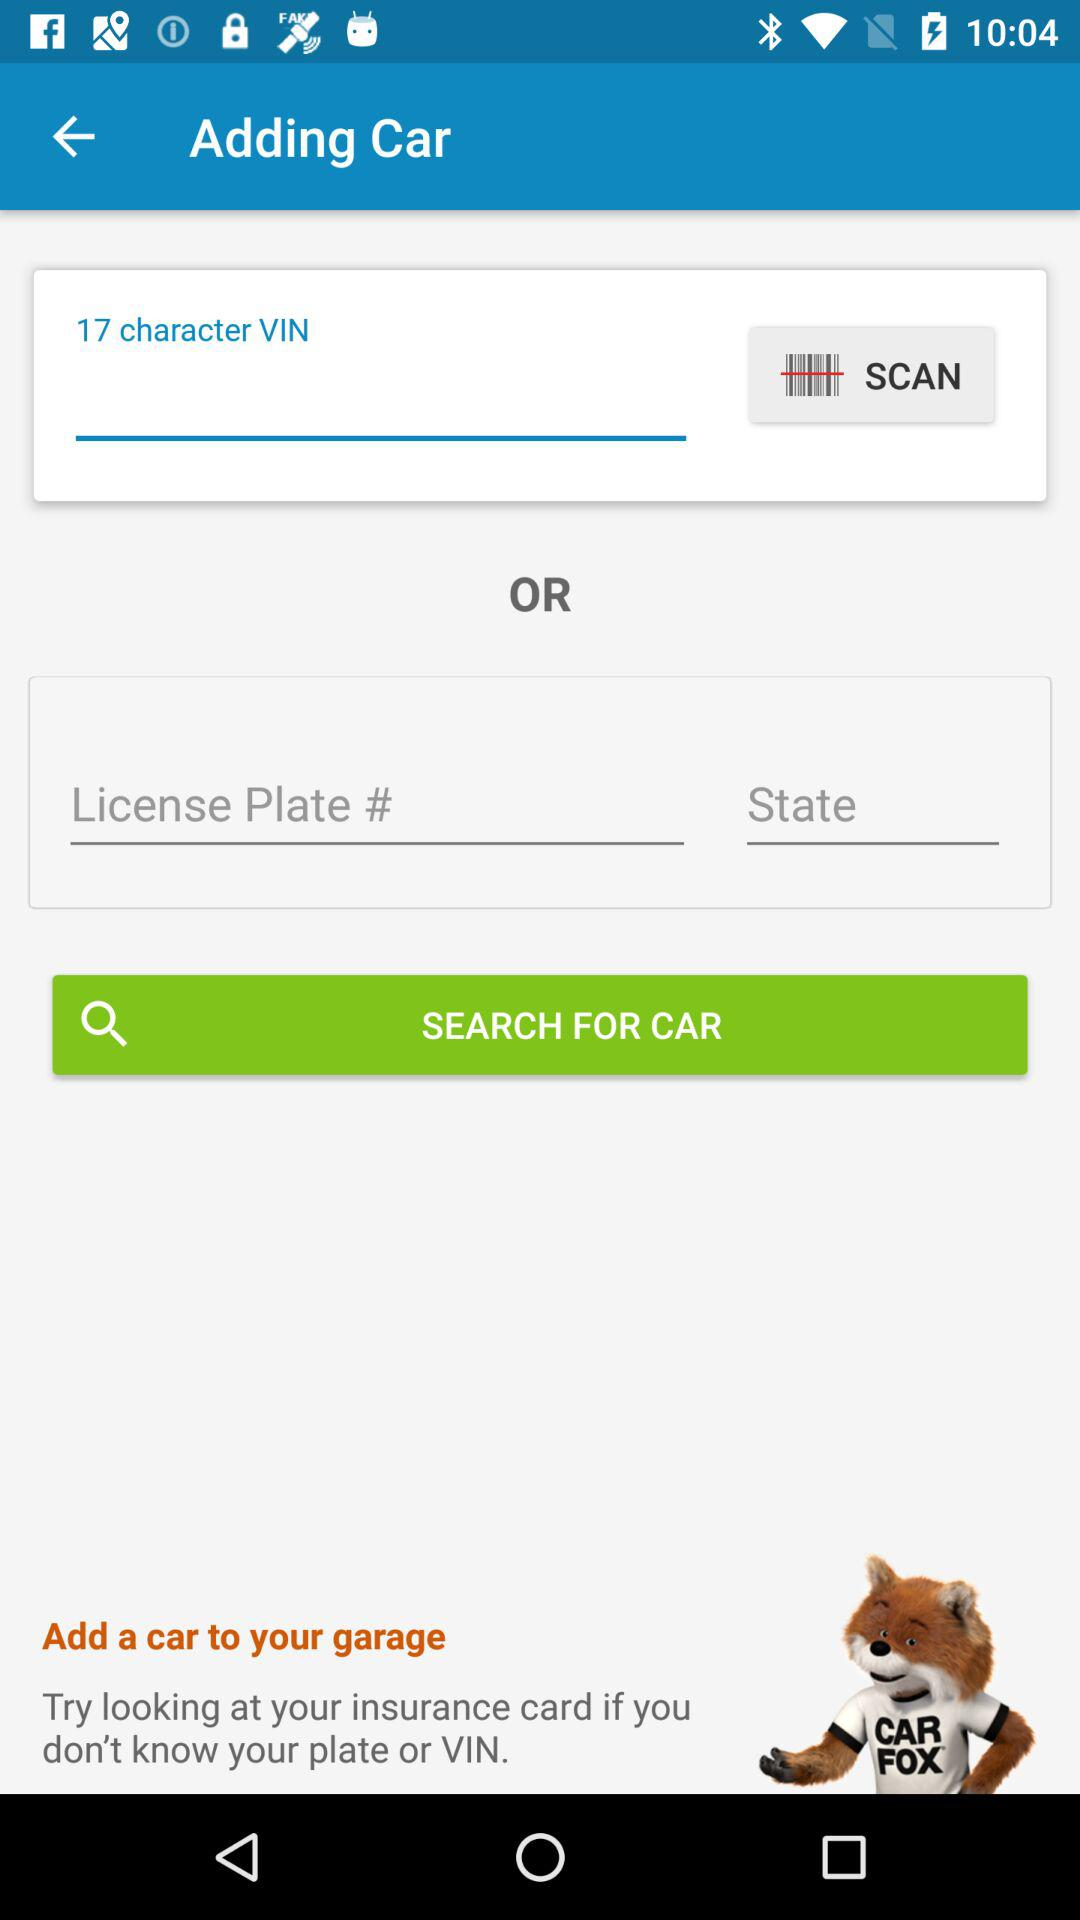How many text inputs are there for the user to fill out?
Answer the question using a single word or phrase. 3 